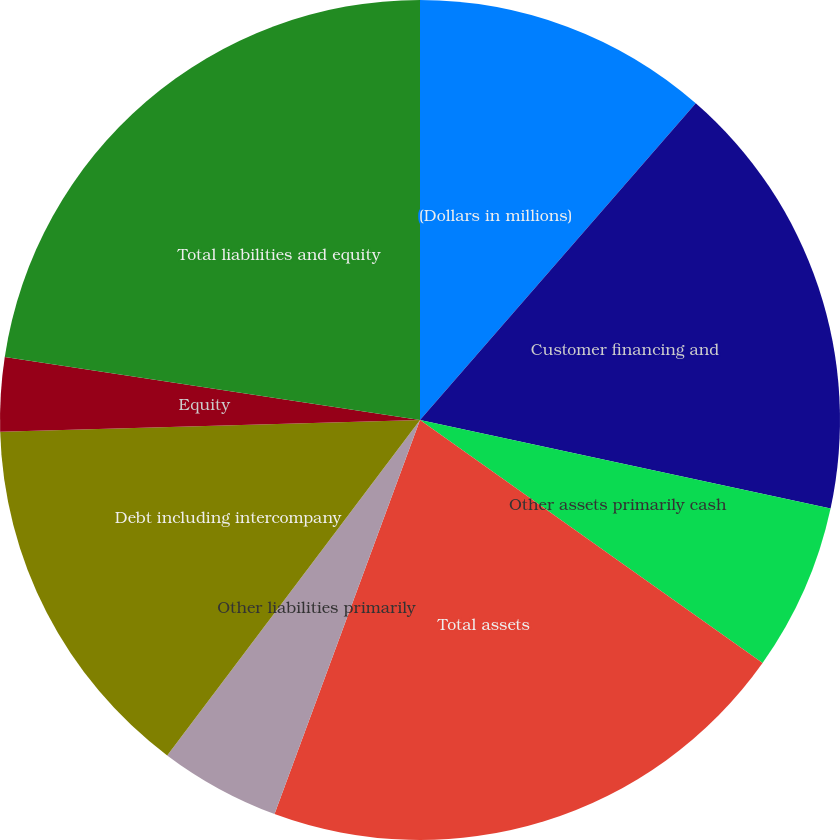Convert chart to OTSL. <chart><loc_0><loc_0><loc_500><loc_500><pie_chart><fcel>(Dollars in millions)<fcel>Customer financing and<fcel>Other assets primarily cash<fcel>Total assets<fcel>Other liabilities primarily<fcel>Debt including intercompany<fcel>Equity<fcel>Total liabilities and equity<nl><fcel>11.4%<fcel>16.98%<fcel>6.44%<fcel>20.81%<fcel>4.65%<fcel>14.27%<fcel>2.85%<fcel>22.6%<nl></chart> 